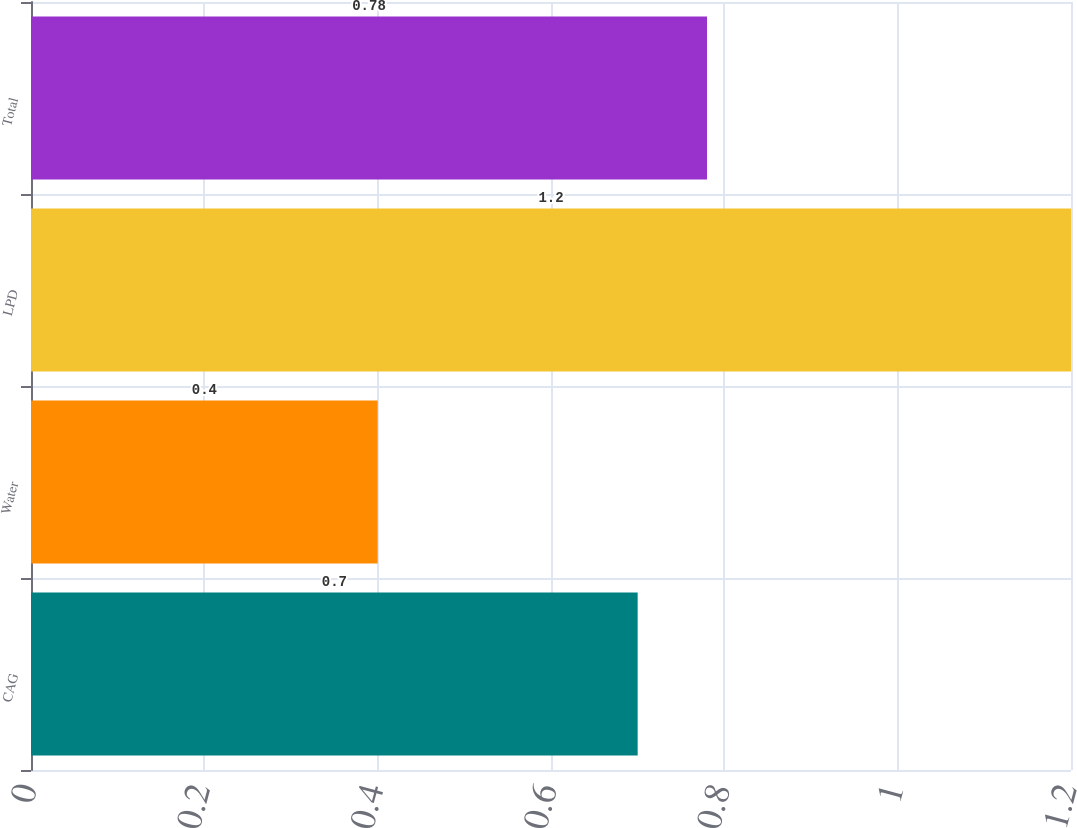Convert chart. <chart><loc_0><loc_0><loc_500><loc_500><bar_chart><fcel>CAG<fcel>Water<fcel>LPD<fcel>Total<nl><fcel>0.7<fcel>0.4<fcel>1.2<fcel>0.78<nl></chart> 